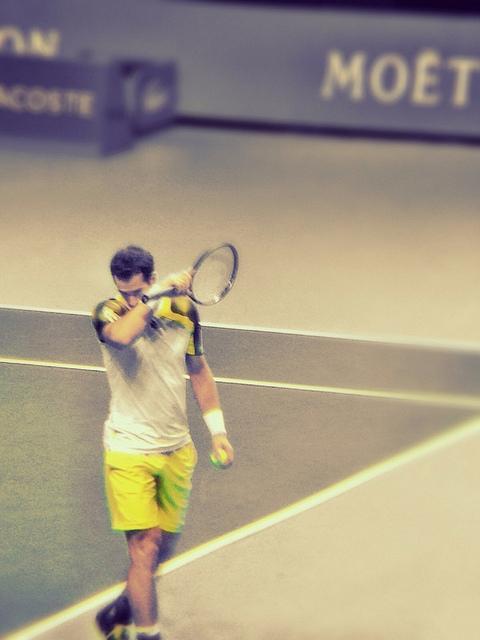How many black railroad cars are at the train station?
Give a very brief answer. 0. 